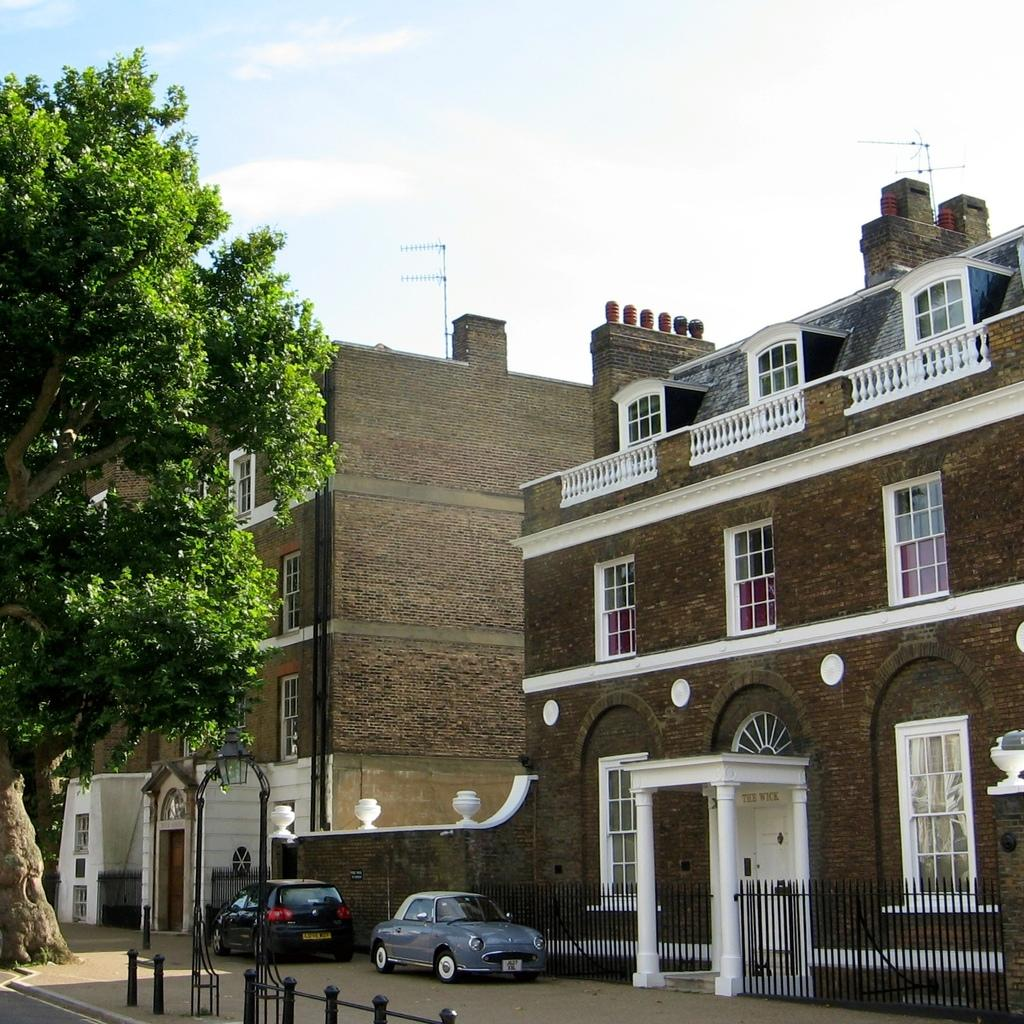What type of structures can be seen in the image? There are buildings in the image. Where are the vehicles located in the image? The vehicles are in the right corner of the image. What type of plant is in the left corner of the image? There is a tree in the left corner of the image. How many elbows can be seen in the image? There are no elbows visible in the image. What type of care is being provided to the tree in the image? There is no indication of care being provided to the tree in the image; it is simply a tree in the left corner. 